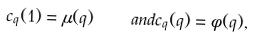Convert formula to latex. <formula><loc_0><loc_0><loc_500><loc_500>c _ { q } ( 1 ) = \mu ( q ) \quad a n d c _ { q } ( q ) = \phi ( q ) ,</formula> 